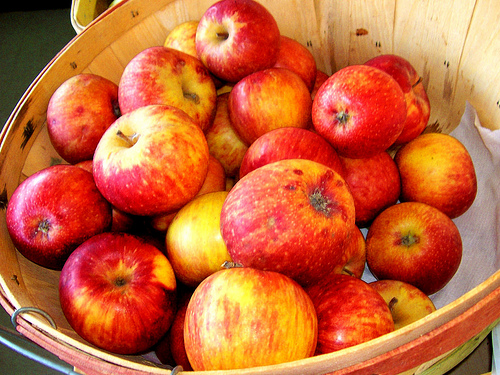<image>
Is there a apple in the box? Yes. The apple is contained within or inside the box, showing a containment relationship. 